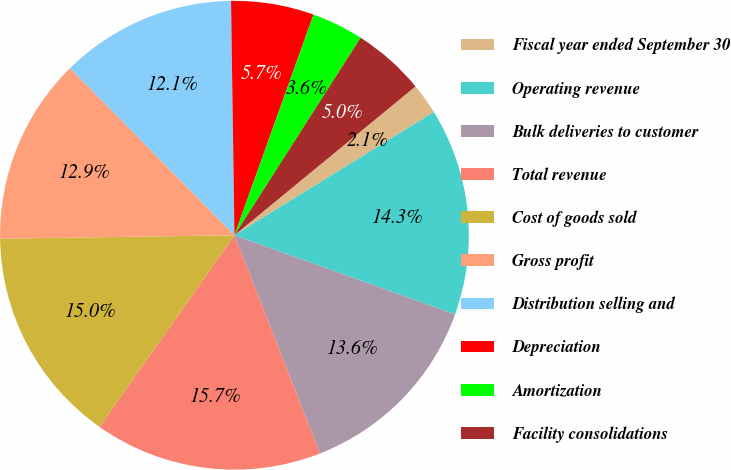<chart> <loc_0><loc_0><loc_500><loc_500><pie_chart><fcel>Fiscal year ended September 30<fcel>Operating revenue<fcel>Bulk deliveries to customer<fcel>Total revenue<fcel>Cost of goods sold<fcel>Gross profit<fcel>Distribution selling and<fcel>Depreciation<fcel>Amortization<fcel>Facility consolidations<nl><fcel>2.14%<fcel>14.29%<fcel>13.57%<fcel>15.71%<fcel>15.0%<fcel>12.86%<fcel>12.14%<fcel>5.71%<fcel>3.57%<fcel>5.0%<nl></chart> 